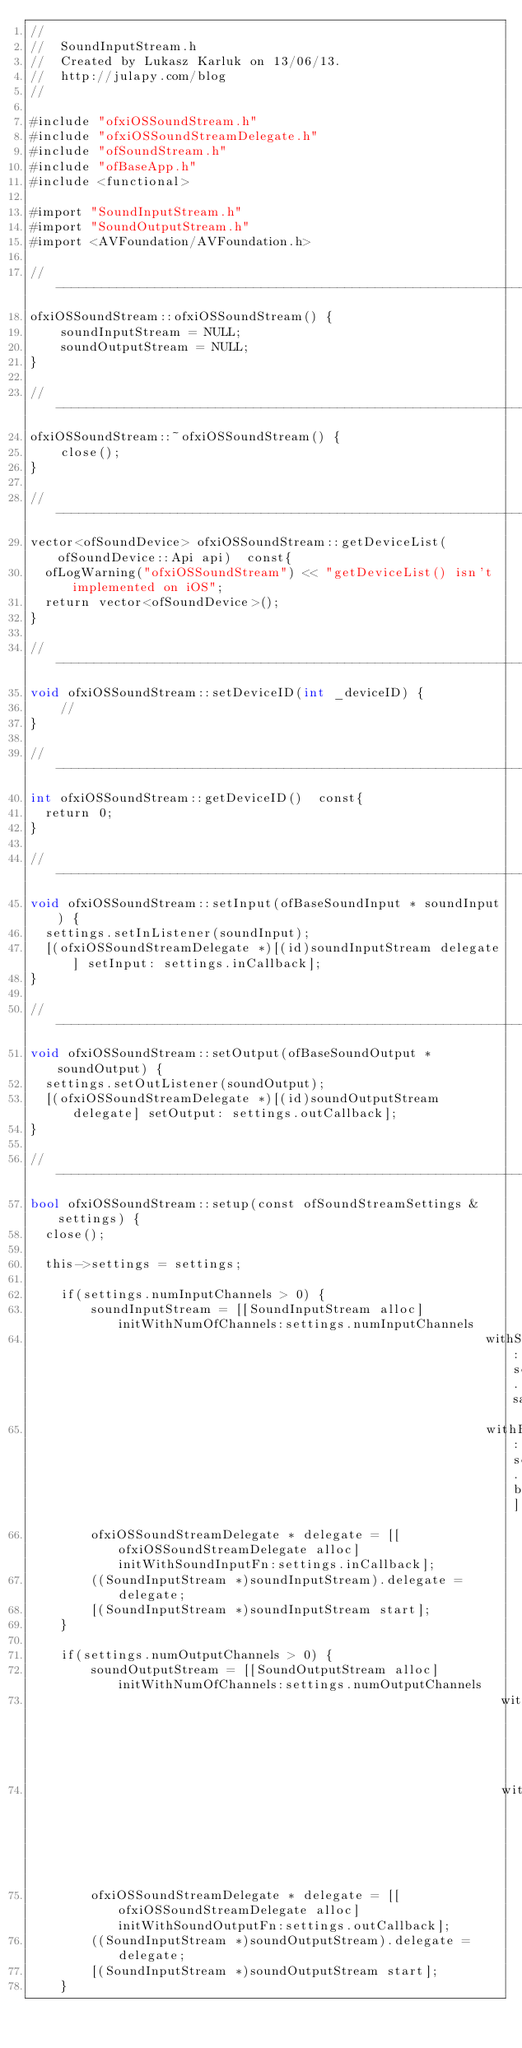<code> <loc_0><loc_0><loc_500><loc_500><_ObjectiveC_>//
//  SoundInputStream.h
//  Created by Lukasz Karluk on 13/06/13.
//  http://julapy.com/blog
//

#include "ofxiOSSoundStream.h"
#include "ofxiOSSoundStreamDelegate.h"
#include "ofSoundStream.h"
#include "ofBaseApp.h"
#include <functional>

#import "SoundInputStream.h"
#import "SoundOutputStream.h"
#import <AVFoundation/AVFoundation.h>

//------------------------------------------------------------------------------
ofxiOSSoundStream::ofxiOSSoundStream() {
    soundInputStream = NULL;
    soundOutputStream = NULL;
}

//------------------------------------------------------------------------------
ofxiOSSoundStream::~ofxiOSSoundStream() {
    close();
}

//------------------------------------------------------------------------------
vector<ofSoundDevice> ofxiOSSoundStream::getDeviceList(ofSoundDevice::Api api)  const{
	ofLogWarning("ofxiOSSoundStream") << "getDeviceList() isn't implemented on iOS";
	return vector<ofSoundDevice>();
}

//------------------------------------------------------------------------------
void ofxiOSSoundStream::setDeviceID(int _deviceID) {
    //
}

//------------------------------------------------------------------------------
int ofxiOSSoundStream::getDeviceID()  const{
	return 0;
}

//------------------------------------------------------------------------------
void ofxiOSSoundStream::setInput(ofBaseSoundInput * soundInput) {
	settings.setInListener(soundInput);
	[(ofxiOSSoundStreamDelegate *)[(id)soundInputStream delegate] setInput: settings.inCallback];
}

//------------------------------------------------------------------------------
void ofxiOSSoundStream::setOutput(ofBaseSoundOutput * soundOutput) {
	settings.setOutListener(soundOutput);
	[(ofxiOSSoundStreamDelegate *)[(id)soundOutputStream delegate] setOutput: settings.outCallback];
}

//------------------------------------------------------------------------------
bool ofxiOSSoundStream::setup(const ofSoundStreamSettings & settings) {
	close();
	
	this->settings = settings;
	
    if(settings.numInputChannels > 0) {
        soundInputStream = [[SoundInputStream alloc] initWithNumOfChannels:settings.numInputChannels
                                                            withSampleRate:settings.sampleRate
                                                            withBufferSize:settings.bufferSize];
        ofxiOSSoundStreamDelegate * delegate = [[ofxiOSSoundStreamDelegate alloc] initWithSoundInputFn:settings.inCallback];
        ((SoundInputStream *)soundInputStream).delegate = delegate;
        [(SoundInputStream *)soundInputStream start];
    }
    
    if(settings.numOutputChannels > 0) {
        soundOutputStream = [[SoundOutputStream alloc] initWithNumOfChannels:settings.numOutputChannels
                                                              withSampleRate:settings.sampleRate
                                                              withBufferSize:settings.bufferSize];
        ofxiOSSoundStreamDelegate * delegate = [[ofxiOSSoundStreamDelegate alloc] initWithSoundOutputFn:settings.outCallback];
        ((SoundInputStream *)soundOutputStream).delegate = delegate;
        [(SoundInputStream *)soundOutputStream start];
    }
    </code> 